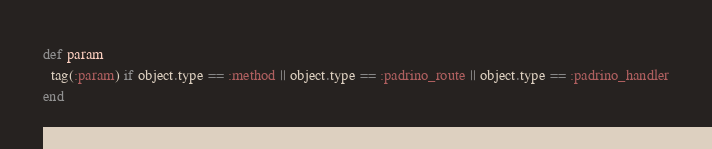Convert code to text. <code><loc_0><loc_0><loc_500><loc_500><_Ruby_>def param
  tag(:param) if object.type == :method || object.type == :padrino_route || object.type == :padrino_handler
end
</code> 